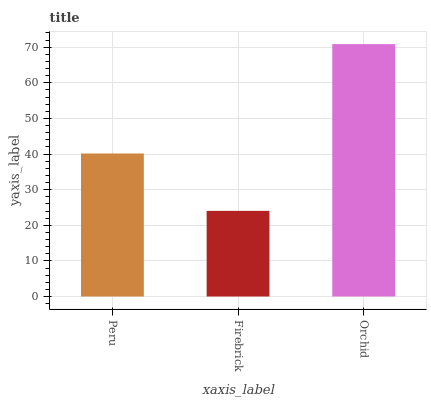Is Firebrick the minimum?
Answer yes or no. Yes. Is Orchid the maximum?
Answer yes or no. Yes. Is Orchid the minimum?
Answer yes or no. No. Is Firebrick the maximum?
Answer yes or no. No. Is Orchid greater than Firebrick?
Answer yes or no. Yes. Is Firebrick less than Orchid?
Answer yes or no. Yes. Is Firebrick greater than Orchid?
Answer yes or no. No. Is Orchid less than Firebrick?
Answer yes or no. No. Is Peru the high median?
Answer yes or no. Yes. Is Peru the low median?
Answer yes or no. Yes. Is Firebrick the high median?
Answer yes or no. No. Is Firebrick the low median?
Answer yes or no. No. 